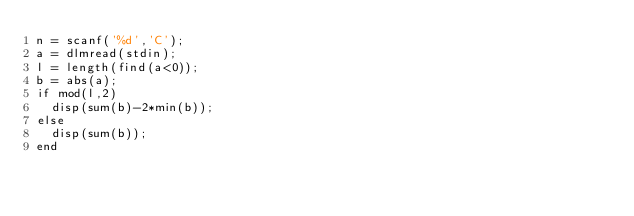<code> <loc_0><loc_0><loc_500><loc_500><_Octave_>n = scanf('%d','C');
a = dlmread(stdin);
l = length(find(a<0));
b = abs(a);
if mod(l,2)
	disp(sum(b)-2*min(b));
else
	disp(sum(b));
end

</code> 